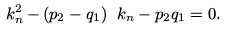<formula> <loc_0><loc_0><loc_500><loc_500>\ k _ { n } ^ { 2 } - ( p _ { 2 } - q _ { 1 } ) \ k _ { n } - p _ { 2 } q _ { 1 } = 0 .</formula> 